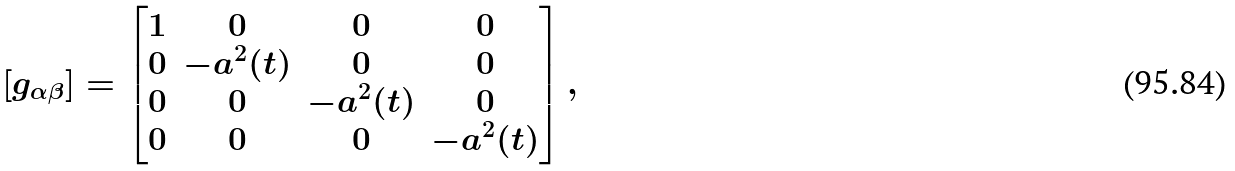<formula> <loc_0><loc_0><loc_500><loc_500>\left [ g _ { \alpha \beta } \right ] = \begin{bmatrix} 1 & 0 & 0 & 0 \\ 0 & - a ^ { 2 } ( t ) & 0 & 0 \\ 0 & 0 & - a ^ { 2 } ( t ) & 0 \\ 0 & 0 & 0 & - a ^ { 2 } ( t ) \end{bmatrix} ,</formula> 